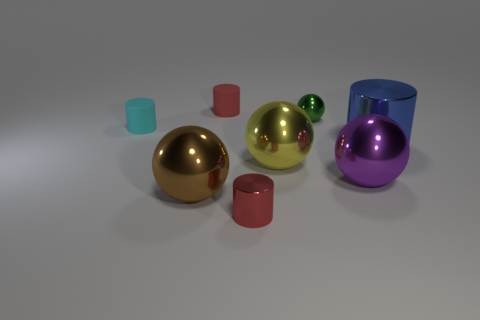Subtract all small spheres. How many spheres are left? 3 Subtract all red cylinders. How many cylinders are left? 2 Add 2 big blue metal cylinders. How many objects exist? 10 Subtract 0 cyan spheres. How many objects are left? 8 Subtract 1 balls. How many balls are left? 3 Subtract all yellow spheres. Subtract all purple cylinders. How many spheres are left? 3 Subtract all cyan blocks. How many cyan cylinders are left? 1 Subtract all large yellow matte cylinders. Subtract all tiny rubber cylinders. How many objects are left? 6 Add 6 large yellow shiny spheres. How many large yellow shiny spheres are left? 7 Add 8 large blue cylinders. How many large blue cylinders exist? 9 